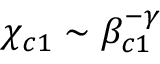Convert formula to latex. <formula><loc_0><loc_0><loc_500><loc_500>\chi _ { c 1 } \sim \beta _ { c 1 } ^ { - \gamma }</formula> 